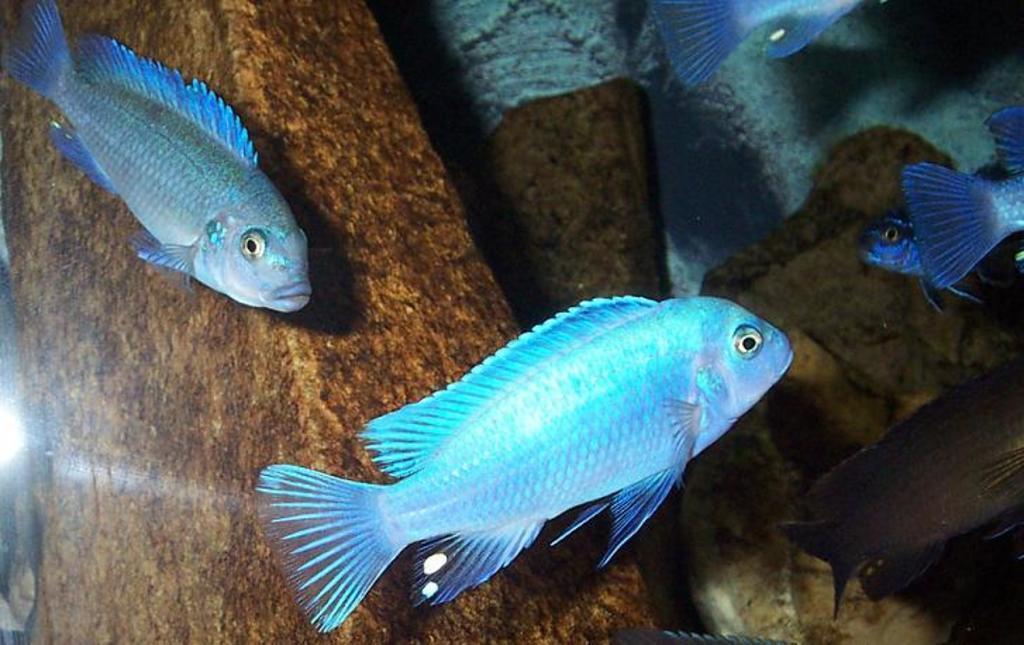In one or two sentences, can you explain what this image depicts? In the foreground of this image, there are fish in the water where we can see few objects and the white sand. 